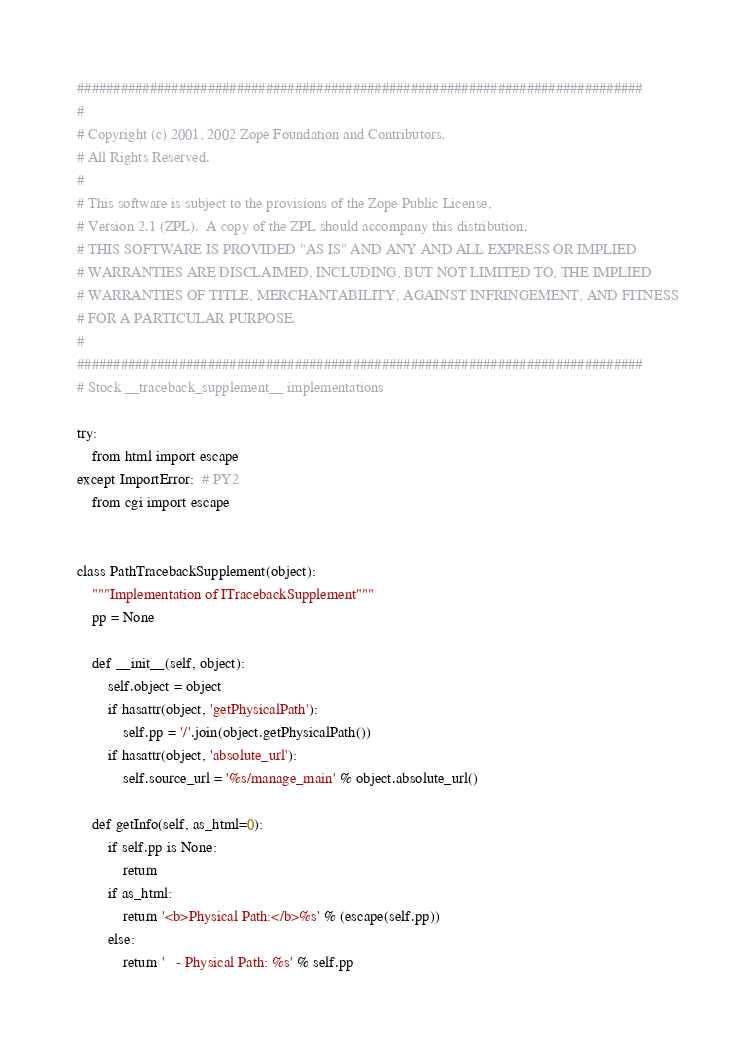<code> <loc_0><loc_0><loc_500><loc_500><_Python_>##############################################################################
#
# Copyright (c) 2001, 2002 Zope Foundation and Contributors.
# All Rights Reserved.
#
# This software is subject to the provisions of the Zope Public License,
# Version 2.1 (ZPL).  A copy of the ZPL should accompany this distribution.
# THIS SOFTWARE IS PROVIDED "AS IS" AND ANY AND ALL EXPRESS OR IMPLIED
# WARRANTIES ARE DISCLAIMED, INCLUDING, BUT NOT LIMITED TO, THE IMPLIED
# WARRANTIES OF TITLE, MERCHANTABILITY, AGAINST INFRINGEMENT, AND FITNESS
# FOR A PARTICULAR PURPOSE.
#
##############################################################################
# Stock __traceback_supplement__ implementations

try:
    from html import escape
except ImportError:  # PY2
    from cgi import escape


class PathTracebackSupplement(object):
    """Implementation of ITracebackSupplement"""
    pp = None

    def __init__(self, object):
        self.object = object
        if hasattr(object, 'getPhysicalPath'):
            self.pp = '/'.join(object.getPhysicalPath())
        if hasattr(object, 'absolute_url'):
            self.source_url = '%s/manage_main' % object.absolute_url()

    def getInfo(self, as_html=0):
        if self.pp is None:
            return
        if as_html:
            return '<b>Physical Path:</b>%s' % (escape(self.pp))
        else:
            return '   - Physical Path: %s' % self.pp
</code> 